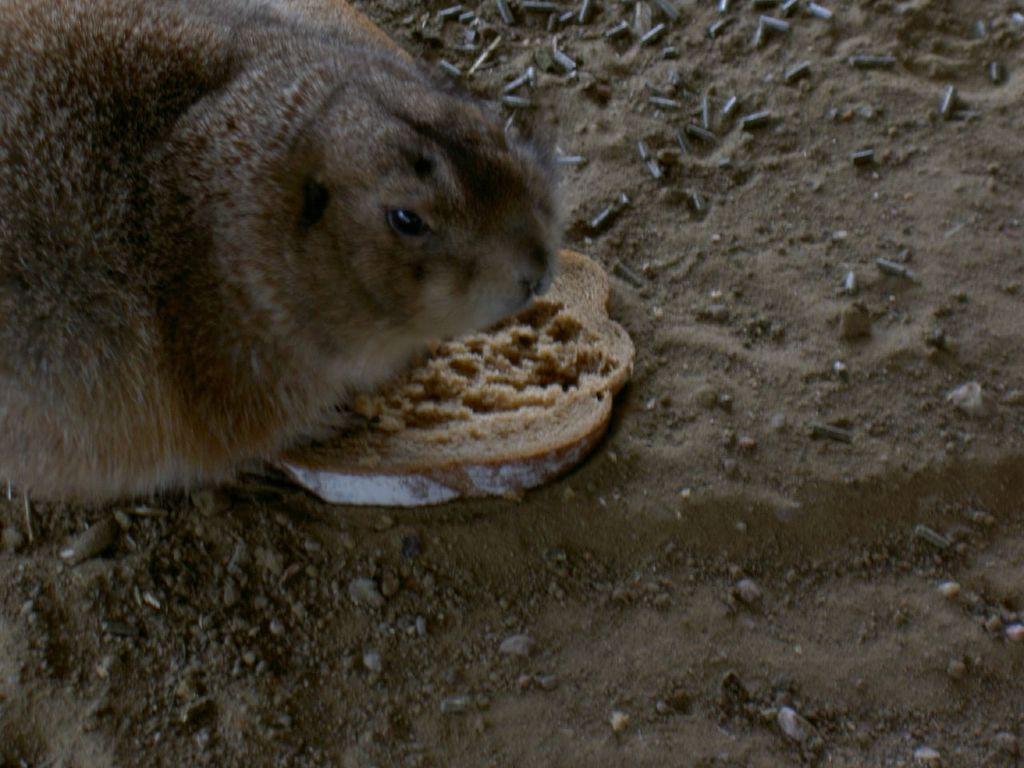In one or two sentences, can you explain what this image depicts? In this image we can see an animal, a bread slice and some stones on the ground. 